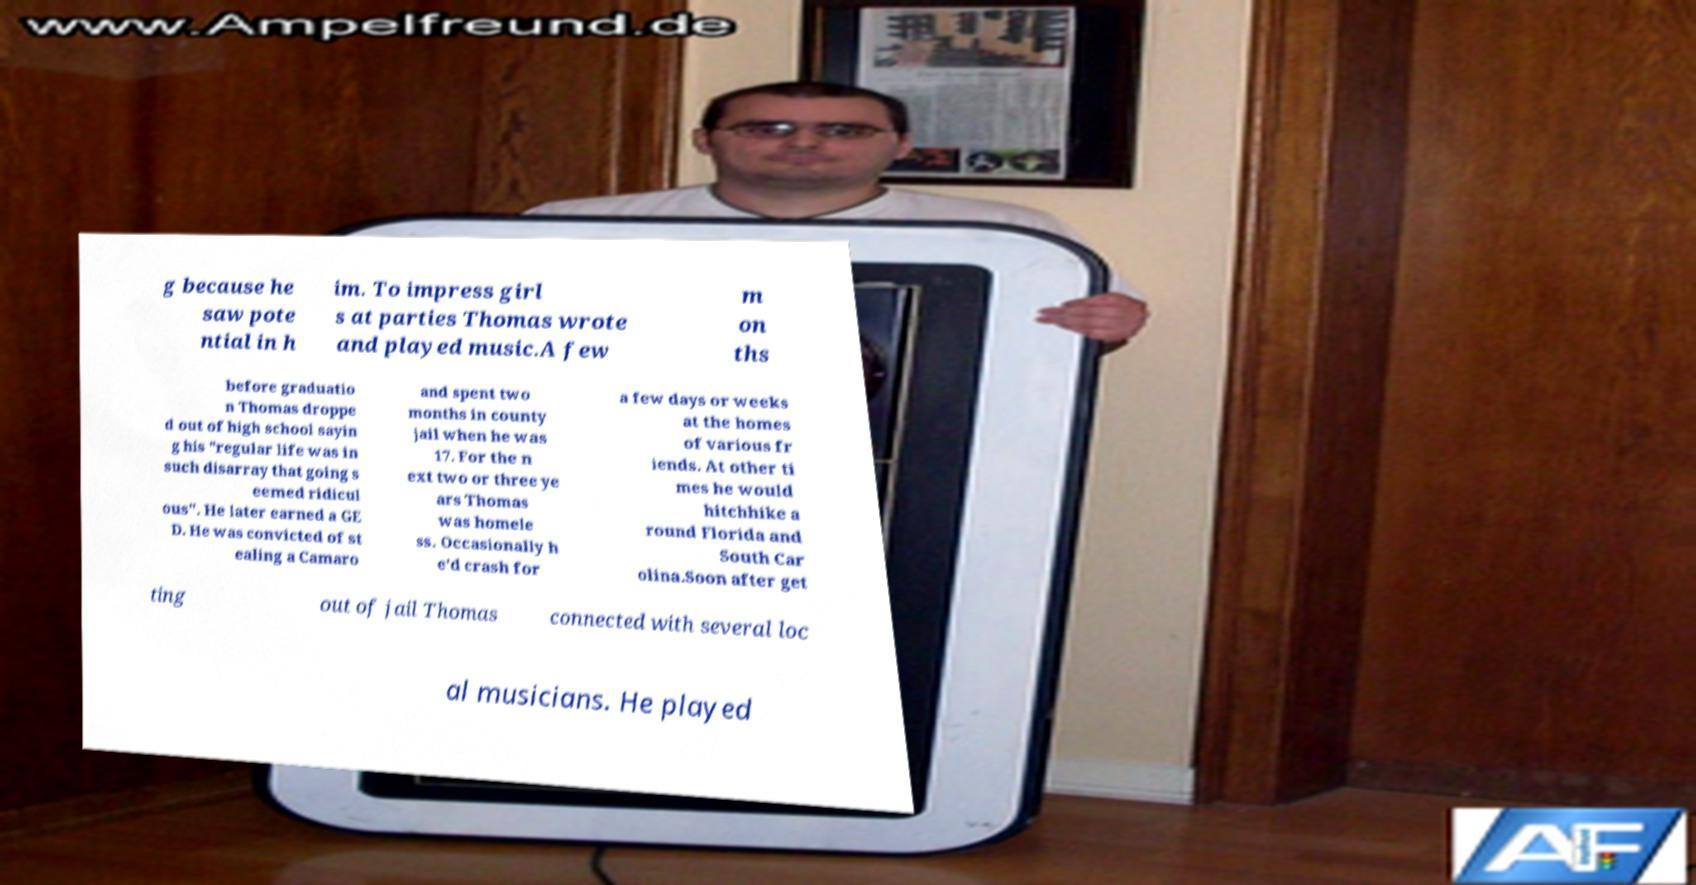Can you read and provide the text displayed in the image?This photo seems to have some interesting text. Can you extract and type it out for me? g because he saw pote ntial in h im. To impress girl s at parties Thomas wrote and played music.A few m on ths before graduatio n Thomas droppe d out of high school sayin g his "regular life was in such disarray that going s eemed ridicul ous". He later earned a GE D. He was convicted of st ealing a Camaro and spent two months in county jail when he was 17. For the n ext two or three ye ars Thomas was homele ss. Occasionally h e'd crash for a few days or weeks at the homes of various fr iends. At other ti mes he would hitchhike a round Florida and South Car olina.Soon after get ting out of jail Thomas connected with several loc al musicians. He played 